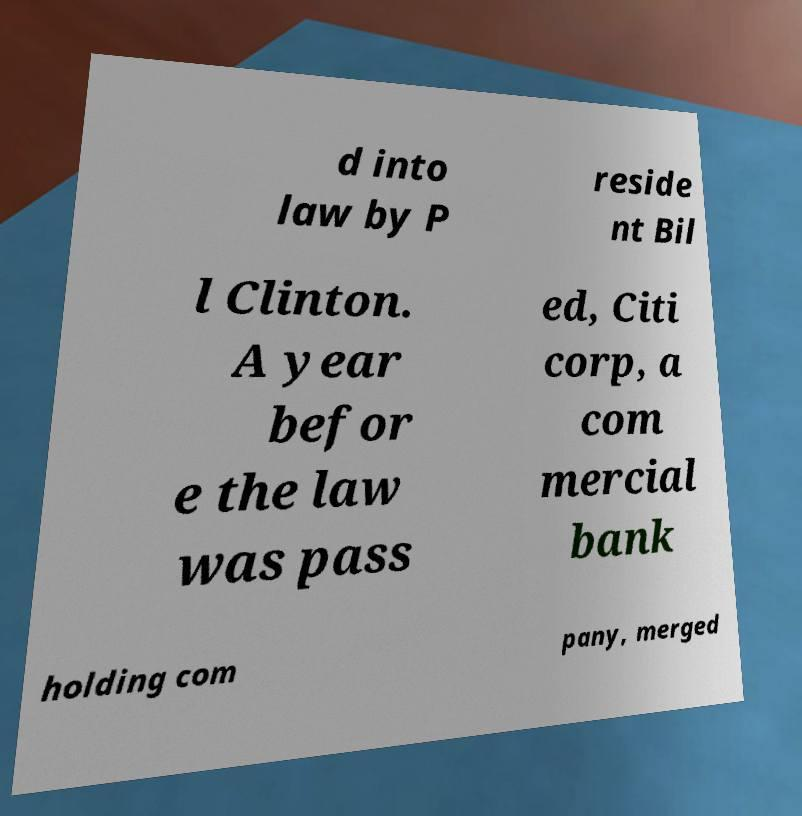I need the written content from this picture converted into text. Can you do that? d into law by P reside nt Bil l Clinton. A year befor e the law was pass ed, Citi corp, a com mercial bank holding com pany, merged 